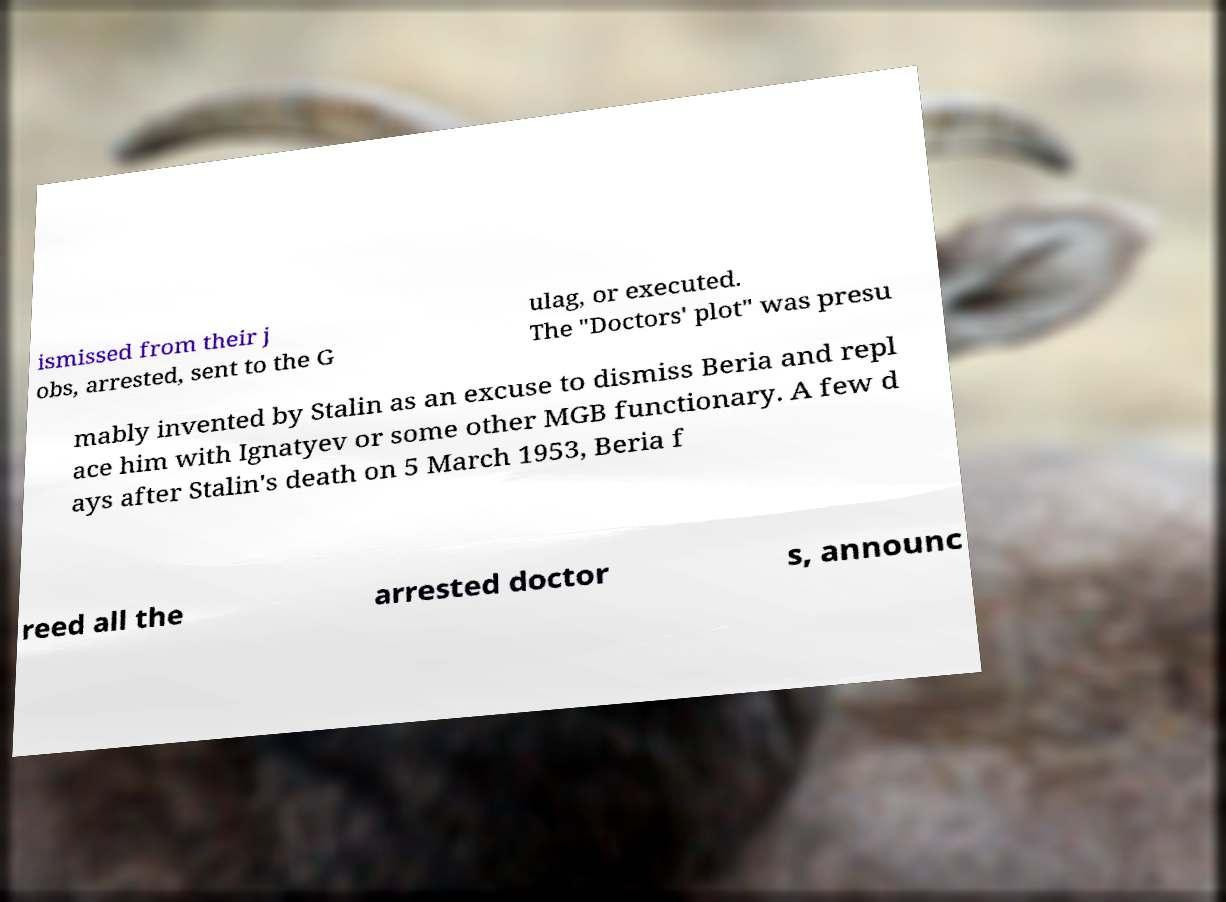For documentation purposes, I need the text within this image transcribed. Could you provide that? ismissed from their j obs, arrested, sent to the G ulag, or executed. The "Doctors' plot" was presu mably invented by Stalin as an excuse to dismiss Beria and repl ace him with Ignatyev or some other MGB functionary. A few d ays after Stalin's death on 5 March 1953, Beria f reed all the arrested doctor s, announc 